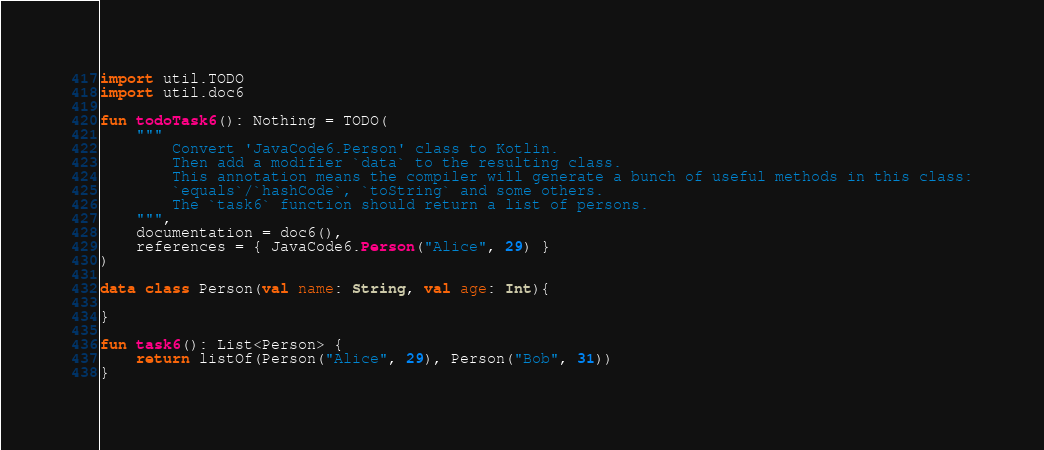Convert code to text. <code><loc_0><loc_0><loc_500><loc_500><_Kotlin_>import util.TODO
import util.doc6

fun todoTask6(): Nothing = TODO(
    """
        Convert 'JavaCode6.Person' class to Kotlin.
        Then add a modifier `data` to the resulting class.
        This annotation means the compiler will generate a bunch of useful methods in this class:
        `equals`/`hashCode`, `toString` and some others.
        The `task6` function should return a list of persons.
    """,
    documentation = doc6(),
    references = { JavaCode6.Person("Alice", 29) }
)

data class Person(val name: String, val age: Int){

}

fun task6(): List<Person> {
    return listOf(Person("Alice", 29), Person("Bob", 31))
}

</code> 